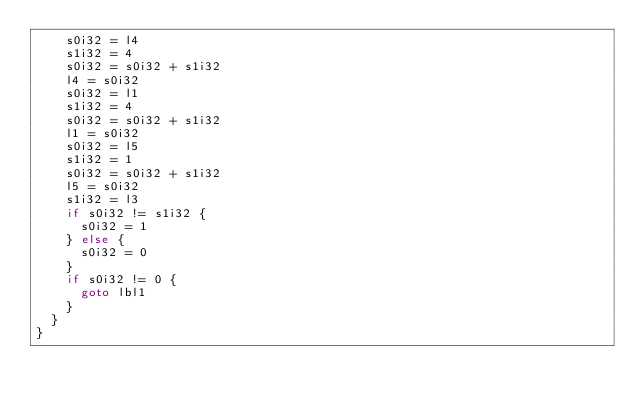Convert code to text. <code><loc_0><loc_0><loc_500><loc_500><_Go_>		s0i32 = l4
		s1i32 = 4
		s0i32 = s0i32 + s1i32
		l4 = s0i32
		s0i32 = l1
		s1i32 = 4
		s0i32 = s0i32 + s1i32
		l1 = s0i32
		s0i32 = l5
		s1i32 = 1
		s0i32 = s0i32 + s1i32
		l5 = s0i32
		s1i32 = l3
		if s0i32 != s1i32 {
			s0i32 = 1
		} else {
			s0i32 = 0
		}
		if s0i32 != 0 {
			goto lbl1
		}
	}
}
</code> 